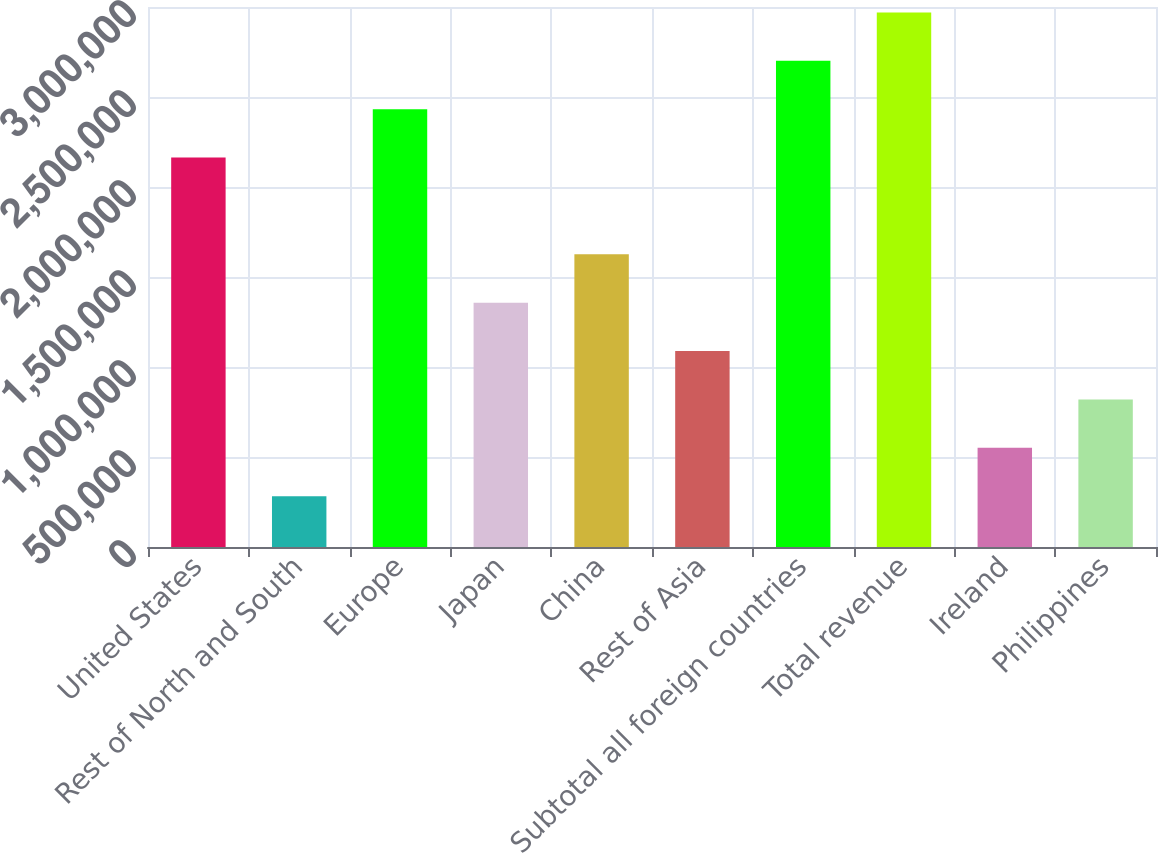Convert chart to OTSL. <chart><loc_0><loc_0><loc_500><loc_500><bar_chart><fcel>United States<fcel>Rest of North and South<fcel>Europe<fcel>Japan<fcel>China<fcel>Rest of Asia<fcel>Subtotal all foreign countries<fcel>Total revenue<fcel>Ireland<fcel>Philippines<nl><fcel>2.16362e+06<fcel>282295<fcel>2.43238e+06<fcel>1.35734e+06<fcel>1.6261e+06<fcel>1.08858e+06<fcel>2.70114e+06<fcel>2.9699e+06<fcel>551056<fcel>819816<nl></chart> 